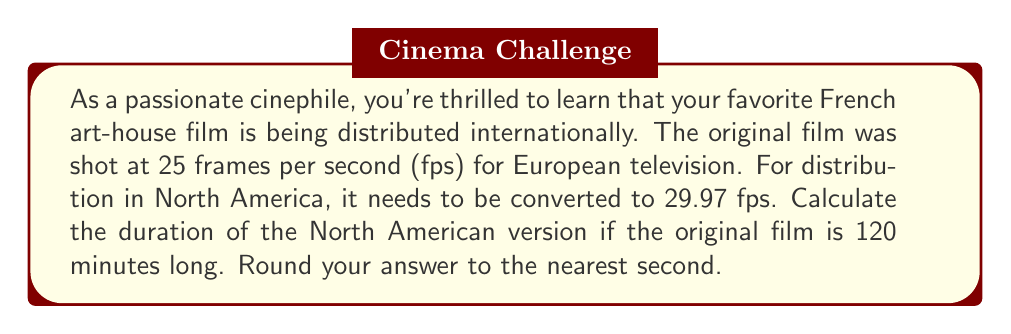Solve this math problem. Let's approach this step-by-step:

1) First, we need to calculate the total number of frames in the original film:
   
   Original duration = 120 minutes = 120 * 60 = 7200 seconds
   Original frame rate = 25 fps
   Total frames = $7200 \times 25 = 180000$ frames

2) Now, we need to determine how long these frames will take to play at the new frame rate:
   
   New frame rate = 29.97 fps
   New duration = $\frac{\text{Total frames}}{\text{New frame rate}}$

3) Let's plug in the numbers:
   
   New duration = $\frac{180000}{29.97} \approx 6005.67$ seconds

4) Convert this to minutes and seconds:
   
   6005.67 seconds = 100 minutes and 5.67 seconds

5) Rounding to the nearest second:
   
   100 minutes and 6 seconds

The emotional impact of this change is subtle but significant. The slightly faster playback might subtly alter the pacing and mood of the film, potentially affecting its poetic rhythm and emotional resonance.
Answer: 100 minutes and 6 seconds 